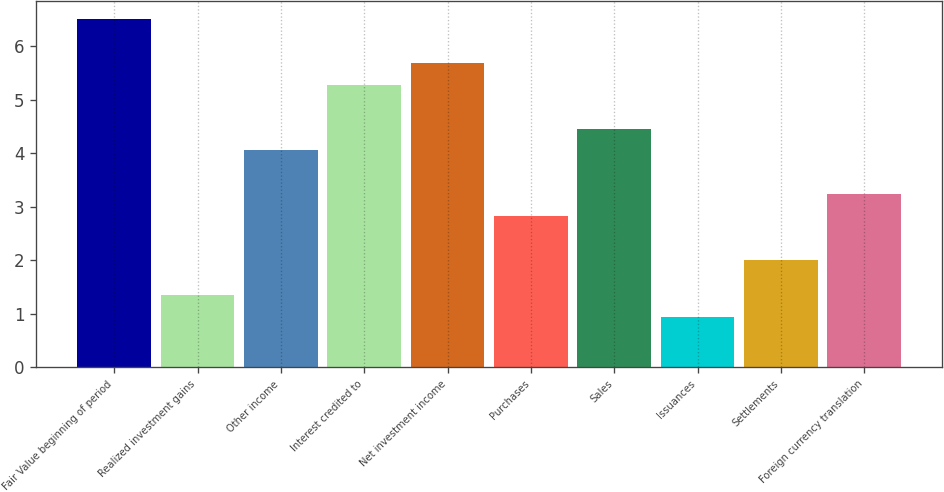Convert chart to OTSL. <chart><loc_0><loc_0><loc_500><loc_500><bar_chart><fcel>Fair Value beginning of period<fcel>Realized investment gains<fcel>Other income<fcel>Interest credited to<fcel>Net investment income<fcel>Purchases<fcel>Sales<fcel>Issuances<fcel>Settlements<fcel>Foreign currency translation<nl><fcel>6.51<fcel>1.34<fcel>4.05<fcel>5.28<fcel>5.69<fcel>2.82<fcel>4.46<fcel>0.93<fcel>2<fcel>3.23<nl></chart> 